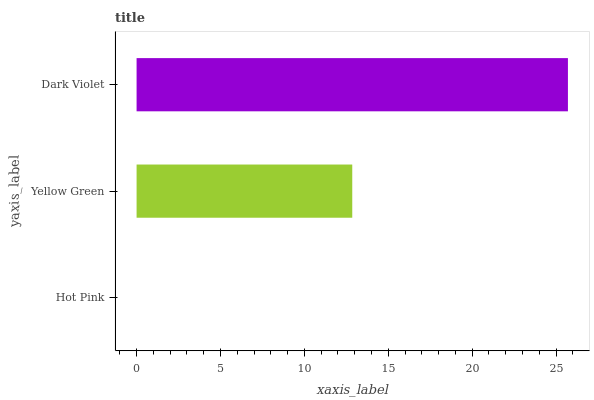Is Hot Pink the minimum?
Answer yes or no. Yes. Is Dark Violet the maximum?
Answer yes or no. Yes. Is Yellow Green the minimum?
Answer yes or no. No. Is Yellow Green the maximum?
Answer yes or no. No. Is Yellow Green greater than Hot Pink?
Answer yes or no. Yes. Is Hot Pink less than Yellow Green?
Answer yes or no. Yes. Is Hot Pink greater than Yellow Green?
Answer yes or no. No. Is Yellow Green less than Hot Pink?
Answer yes or no. No. Is Yellow Green the high median?
Answer yes or no. Yes. Is Yellow Green the low median?
Answer yes or no. Yes. Is Dark Violet the high median?
Answer yes or no. No. Is Hot Pink the low median?
Answer yes or no. No. 